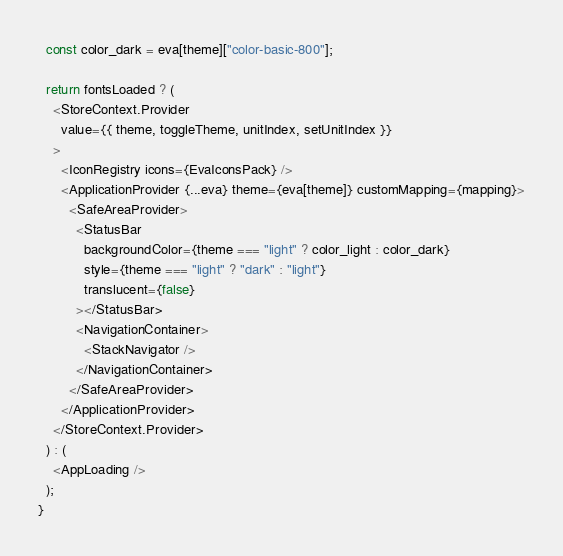<code> <loc_0><loc_0><loc_500><loc_500><_JavaScript_>  const color_dark = eva[theme]["color-basic-800"];

  return fontsLoaded ? (
    <StoreContext.Provider
      value={{ theme, toggleTheme, unitIndex, setUnitIndex }}
    >
      <IconRegistry icons={EvaIconsPack} />
      <ApplicationProvider {...eva} theme={eva[theme]} customMapping={mapping}>
        <SafeAreaProvider>
          <StatusBar
            backgroundColor={theme === "light" ? color_light : color_dark}
            style={theme === "light" ? "dark" : "light"}
            translucent={false}
          ></StatusBar>
          <NavigationContainer>
            <StackNavigator />
          </NavigationContainer>
        </SafeAreaProvider>
      </ApplicationProvider>
    </StoreContext.Provider>
  ) : (
    <AppLoading />
  );
}
</code> 